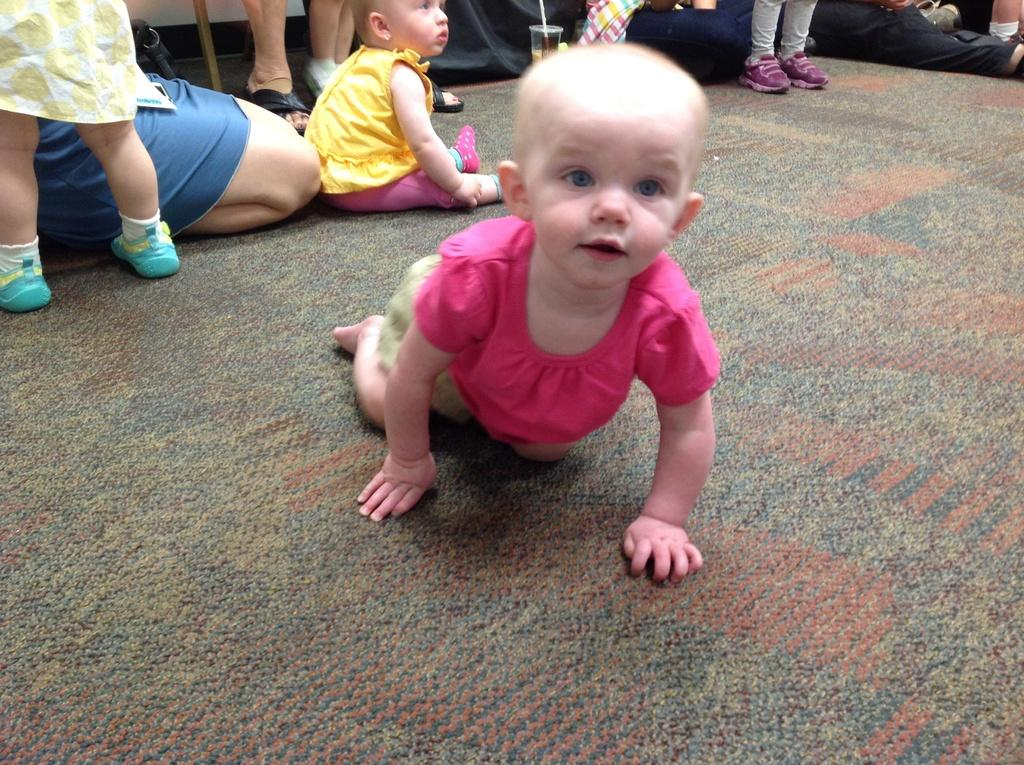What is the kid doing in the image? There is a kid crawling in the image. What can be seen at the top of the image? At the top of the image, there are some persons and a kid sitting. What else is present at the top of the image? There are other objects at the top of the image. What is the surface on which the kid is crawling? The bottom of the image contains the floor. What type of plastic material is being used by the farmer in the image? There is no farmer or plastic material present in the image. 